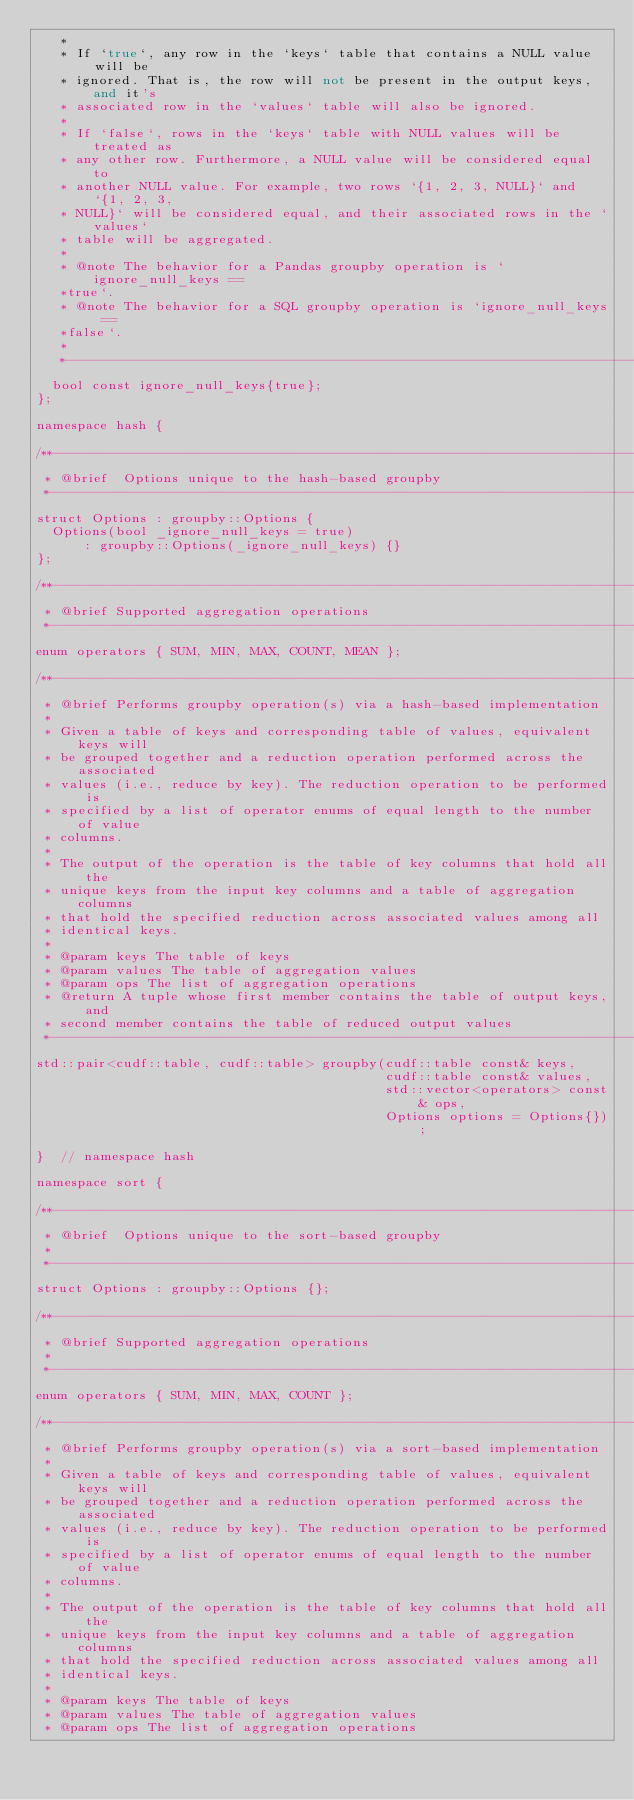Convert code to text. <code><loc_0><loc_0><loc_500><loc_500><_C++_>   *
   * If `true`, any row in the `keys` table that contains a NULL value will be
   * ignored. That is, the row will not be present in the output keys, and it's
   * associated row in the `values` table will also be ignored.
   *
   * If `false`, rows in the `keys` table with NULL values will be treated as
   * any other row. Furthermore, a NULL value will be considered equal to
   * another NULL value. For example, two rows `{1, 2, 3, NULL}` and `{1, 2, 3,
   * NULL}` will be considered equal, and their associated rows in the `values`
   * table will be aggregated.
   *
   * @note The behavior for a Pandas groupby operation is `ignore_null_keys ==
   *true`.
   * @note The behavior for a SQL groupby operation is `ignore_null_keys ==
   *false`.
   *
   *---------------------------------------------------------------------------**/
  bool const ignore_null_keys{true};
};

namespace hash {

/**---------------------------------------------------------------------------*
 * @brief  Options unique to the hash-based groupby
 *---------------------------------------------------------------------------**/
struct Options : groupby::Options {
  Options(bool _ignore_null_keys = true)
      : groupby::Options(_ignore_null_keys) {}
};

/**---------------------------------------------------------------------------*
 * @brief Supported aggregation operations
 *---------------------------------------------------------------------------**/
enum operators { SUM, MIN, MAX, COUNT, MEAN };

/**---------------------------------------------------------------------------*
 * @brief Performs groupby operation(s) via a hash-based implementation
 *
 * Given a table of keys and corresponding table of values, equivalent keys will
 * be grouped together and a reduction operation performed across the associated
 * values (i.e., reduce by key). The reduction operation to be performed is
 * specified by a list of operator enums of equal length to the number of value
 * columns.
 *
 * The output of the operation is the table of key columns that hold all the
 * unique keys from the input key columns and a table of aggregation columns
 * that hold the specified reduction across associated values among all
 * identical keys.
 *
 * @param keys The table of keys
 * @param values The table of aggregation values
 * @param ops The list of aggregation operations
 * @return A tuple whose first member contains the table of output keys, and
 * second member contains the table of reduced output values
 *---------------------------------------------------------------------------**/
std::pair<cudf::table, cudf::table> groupby(cudf::table const& keys,
                                            cudf::table const& values,
                                            std::vector<operators> const& ops,
                                            Options options = Options{});

}  // namespace hash

namespace sort {

/**---------------------------------------------------------------------------*
 * @brief  Options unique to the sort-based groupby
 *
 *---------------------------------------------------------------------------**/
struct Options : groupby::Options {};

/**---------------------------------------------------------------------------*
 * @brief Supported aggregation operations
 *
 *---------------------------------------------------------------------------**/
enum operators { SUM, MIN, MAX, COUNT };

/**---------------------------------------------------------------------------*
 * @brief Performs groupby operation(s) via a sort-based implementation
 *
 * Given a table of keys and corresponding table of values, equivalent keys will
 * be grouped together and a reduction operation performed across the associated
 * values (i.e., reduce by key). The reduction operation to be performed is
 * specified by a list of operator enums of equal length to the number of value
 * columns.
 *
 * The output of the operation is the table of key columns that hold all the
 * unique keys from the input key columns and a table of aggregation columns
 * that hold the specified reduction across associated values among all
 * identical keys.
 *
 * @param keys The table of keys
 * @param values The table of aggregation values
 * @param ops The list of aggregation operations</code> 